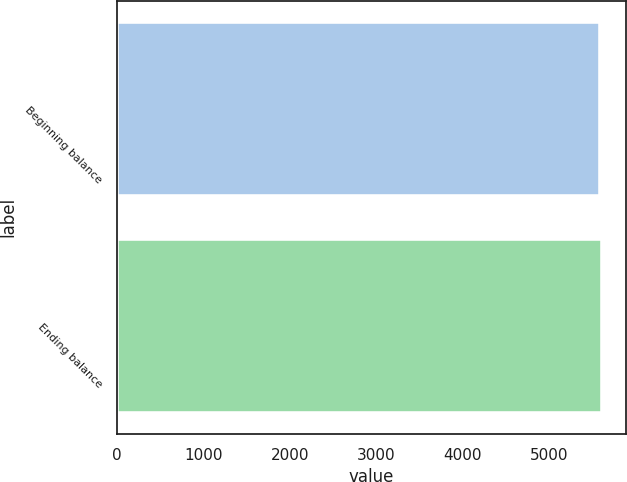<chart> <loc_0><loc_0><loc_500><loc_500><bar_chart><fcel>Beginning balance<fcel>Ending balance<nl><fcel>5591<fcel>5610<nl></chart> 